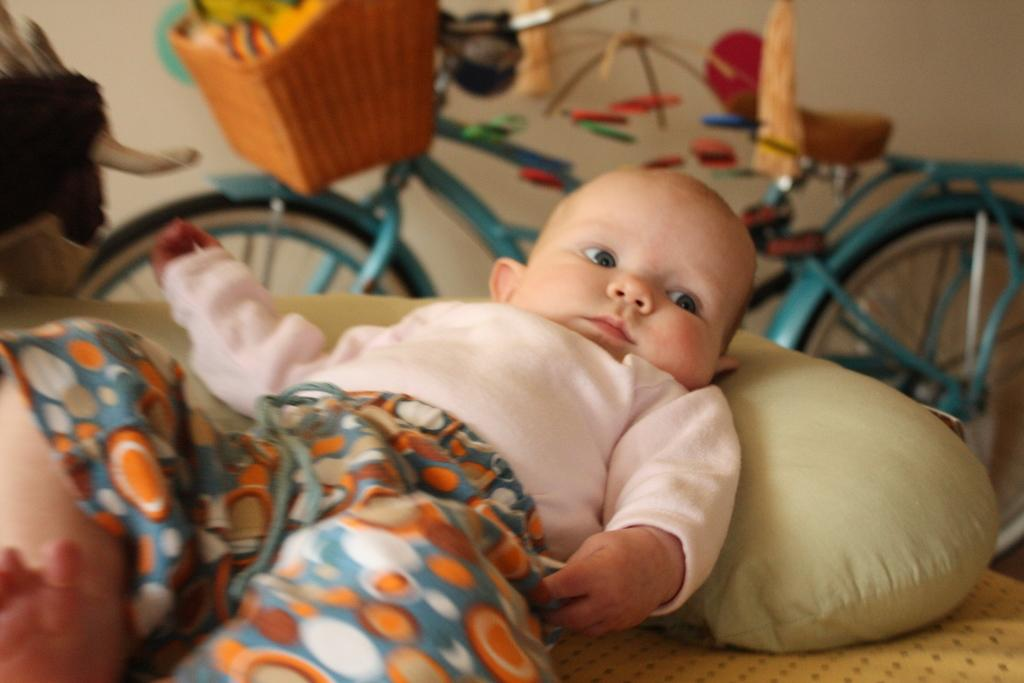What is the main subject of the image? The main subject of the image is a baby lying down. What else can be seen in the image besides the baby? There is a cycle visible in the image. What is the baby's tendency to accumulate wealth in the image? There is no information about the baby's wealth or tendency to accumulate wealth in the image. Is there a lake visible in the image? There is no lake present in the image; it only features a baby and a cycle. 